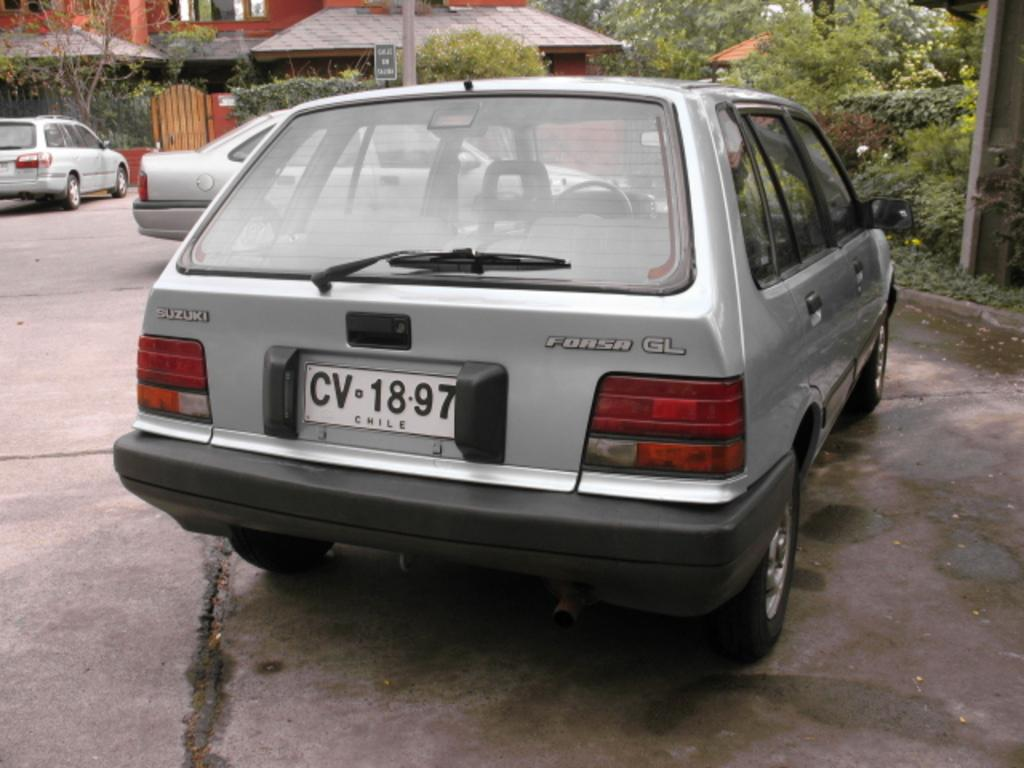<image>
Render a clear and concise summary of the photo. A Suzuki Forsa GL car with license plate CV-1897. 